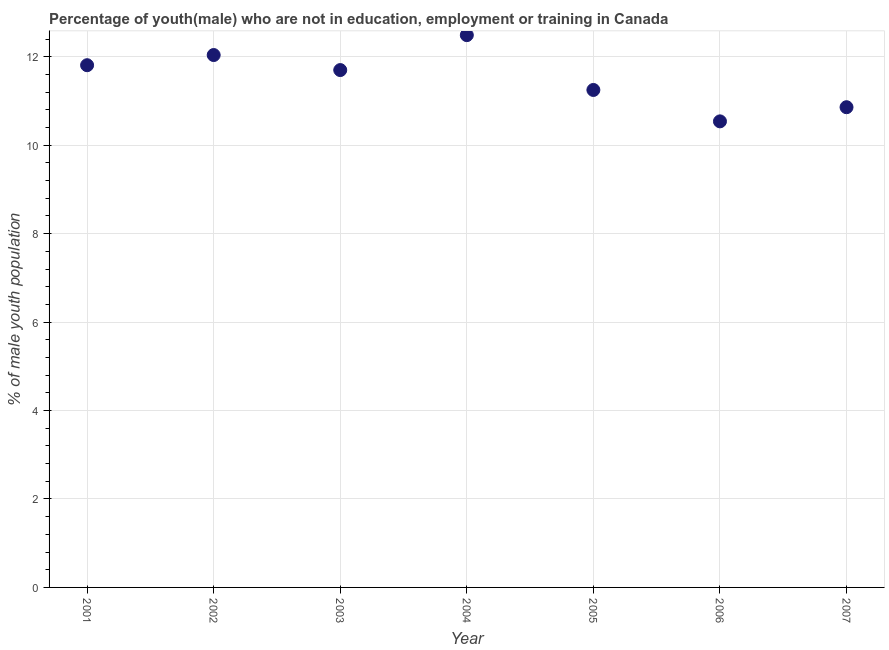What is the unemployed male youth population in 2001?
Your response must be concise. 11.81. Across all years, what is the maximum unemployed male youth population?
Your response must be concise. 12.49. Across all years, what is the minimum unemployed male youth population?
Ensure brevity in your answer.  10.54. In which year was the unemployed male youth population maximum?
Provide a succinct answer. 2004. What is the sum of the unemployed male youth population?
Your answer should be very brief. 80.69. What is the difference between the unemployed male youth population in 2002 and 2004?
Your answer should be very brief. -0.45. What is the average unemployed male youth population per year?
Your response must be concise. 11.53. What is the median unemployed male youth population?
Provide a short and direct response. 11.7. In how many years, is the unemployed male youth population greater than 12 %?
Your response must be concise. 2. What is the ratio of the unemployed male youth population in 2002 to that in 2004?
Provide a succinct answer. 0.96. Is the unemployed male youth population in 2005 less than that in 2006?
Offer a very short reply. No. What is the difference between the highest and the second highest unemployed male youth population?
Provide a short and direct response. 0.45. What is the difference between the highest and the lowest unemployed male youth population?
Your answer should be compact. 1.95. Does the unemployed male youth population monotonically increase over the years?
Your response must be concise. No. How many years are there in the graph?
Your answer should be compact. 7. What is the difference between two consecutive major ticks on the Y-axis?
Offer a terse response. 2. Does the graph contain any zero values?
Your answer should be compact. No. Does the graph contain grids?
Make the answer very short. Yes. What is the title of the graph?
Your answer should be compact. Percentage of youth(male) who are not in education, employment or training in Canada. What is the label or title of the Y-axis?
Your response must be concise. % of male youth population. What is the % of male youth population in 2001?
Your answer should be compact. 11.81. What is the % of male youth population in 2002?
Offer a very short reply. 12.04. What is the % of male youth population in 2003?
Keep it short and to the point. 11.7. What is the % of male youth population in 2004?
Provide a succinct answer. 12.49. What is the % of male youth population in 2005?
Your response must be concise. 11.25. What is the % of male youth population in 2006?
Your answer should be very brief. 10.54. What is the % of male youth population in 2007?
Your answer should be compact. 10.86. What is the difference between the % of male youth population in 2001 and 2002?
Offer a very short reply. -0.23. What is the difference between the % of male youth population in 2001 and 2003?
Ensure brevity in your answer.  0.11. What is the difference between the % of male youth population in 2001 and 2004?
Give a very brief answer. -0.68. What is the difference between the % of male youth population in 2001 and 2005?
Ensure brevity in your answer.  0.56. What is the difference between the % of male youth population in 2001 and 2006?
Your answer should be very brief. 1.27. What is the difference between the % of male youth population in 2001 and 2007?
Ensure brevity in your answer.  0.95. What is the difference between the % of male youth population in 2002 and 2003?
Provide a short and direct response. 0.34. What is the difference between the % of male youth population in 2002 and 2004?
Give a very brief answer. -0.45. What is the difference between the % of male youth population in 2002 and 2005?
Your answer should be compact. 0.79. What is the difference between the % of male youth population in 2002 and 2006?
Ensure brevity in your answer.  1.5. What is the difference between the % of male youth population in 2002 and 2007?
Give a very brief answer. 1.18. What is the difference between the % of male youth population in 2003 and 2004?
Offer a terse response. -0.79. What is the difference between the % of male youth population in 2003 and 2005?
Make the answer very short. 0.45. What is the difference between the % of male youth population in 2003 and 2006?
Make the answer very short. 1.16. What is the difference between the % of male youth population in 2003 and 2007?
Provide a short and direct response. 0.84. What is the difference between the % of male youth population in 2004 and 2005?
Provide a short and direct response. 1.24. What is the difference between the % of male youth population in 2004 and 2006?
Keep it short and to the point. 1.95. What is the difference between the % of male youth population in 2004 and 2007?
Your answer should be very brief. 1.63. What is the difference between the % of male youth population in 2005 and 2006?
Provide a succinct answer. 0.71. What is the difference between the % of male youth population in 2005 and 2007?
Ensure brevity in your answer.  0.39. What is the difference between the % of male youth population in 2006 and 2007?
Your answer should be very brief. -0.32. What is the ratio of the % of male youth population in 2001 to that in 2002?
Ensure brevity in your answer.  0.98. What is the ratio of the % of male youth population in 2001 to that in 2003?
Your answer should be compact. 1.01. What is the ratio of the % of male youth population in 2001 to that in 2004?
Provide a short and direct response. 0.95. What is the ratio of the % of male youth population in 2001 to that in 2005?
Your response must be concise. 1.05. What is the ratio of the % of male youth population in 2001 to that in 2006?
Offer a very short reply. 1.12. What is the ratio of the % of male youth population in 2001 to that in 2007?
Your answer should be very brief. 1.09. What is the ratio of the % of male youth population in 2002 to that in 2004?
Offer a terse response. 0.96. What is the ratio of the % of male youth population in 2002 to that in 2005?
Make the answer very short. 1.07. What is the ratio of the % of male youth population in 2002 to that in 2006?
Give a very brief answer. 1.14. What is the ratio of the % of male youth population in 2002 to that in 2007?
Give a very brief answer. 1.11. What is the ratio of the % of male youth population in 2003 to that in 2004?
Your answer should be compact. 0.94. What is the ratio of the % of male youth population in 2003 to that in 2005?
Offer a very short reply. 1.04. What is the ratio of the % of male youth population in 2003 to that in 2006?
Your answer should be compact. 1.11. What is the ratio of the % of male youth population in 2003 to that in 2007?
Keep it short and to the point. 1.08. What is the ratio of the % of male youth population in 2004 to that in 2005?
Keep it short and to the point. 1.11. What is the ratio of the % of male youth population in 2004 to that in 2006?
Offer a terse response. 1.19. What is the ratio of the % of male youth population in 2004 to that in 2007?
Offer a very short reply. 1.15. What is the ratio of the % of male youth population in 2005 to that in 2006?
Offer a terse response. 1.07. What is the ratio of the % of male youth population in 2005 to that in 2007?
Ensure brevity in your answer.  1.04. What is the ratio of the % of male youth population in 2006 to that in 2007?
Your answer should be compact. 0.97. 